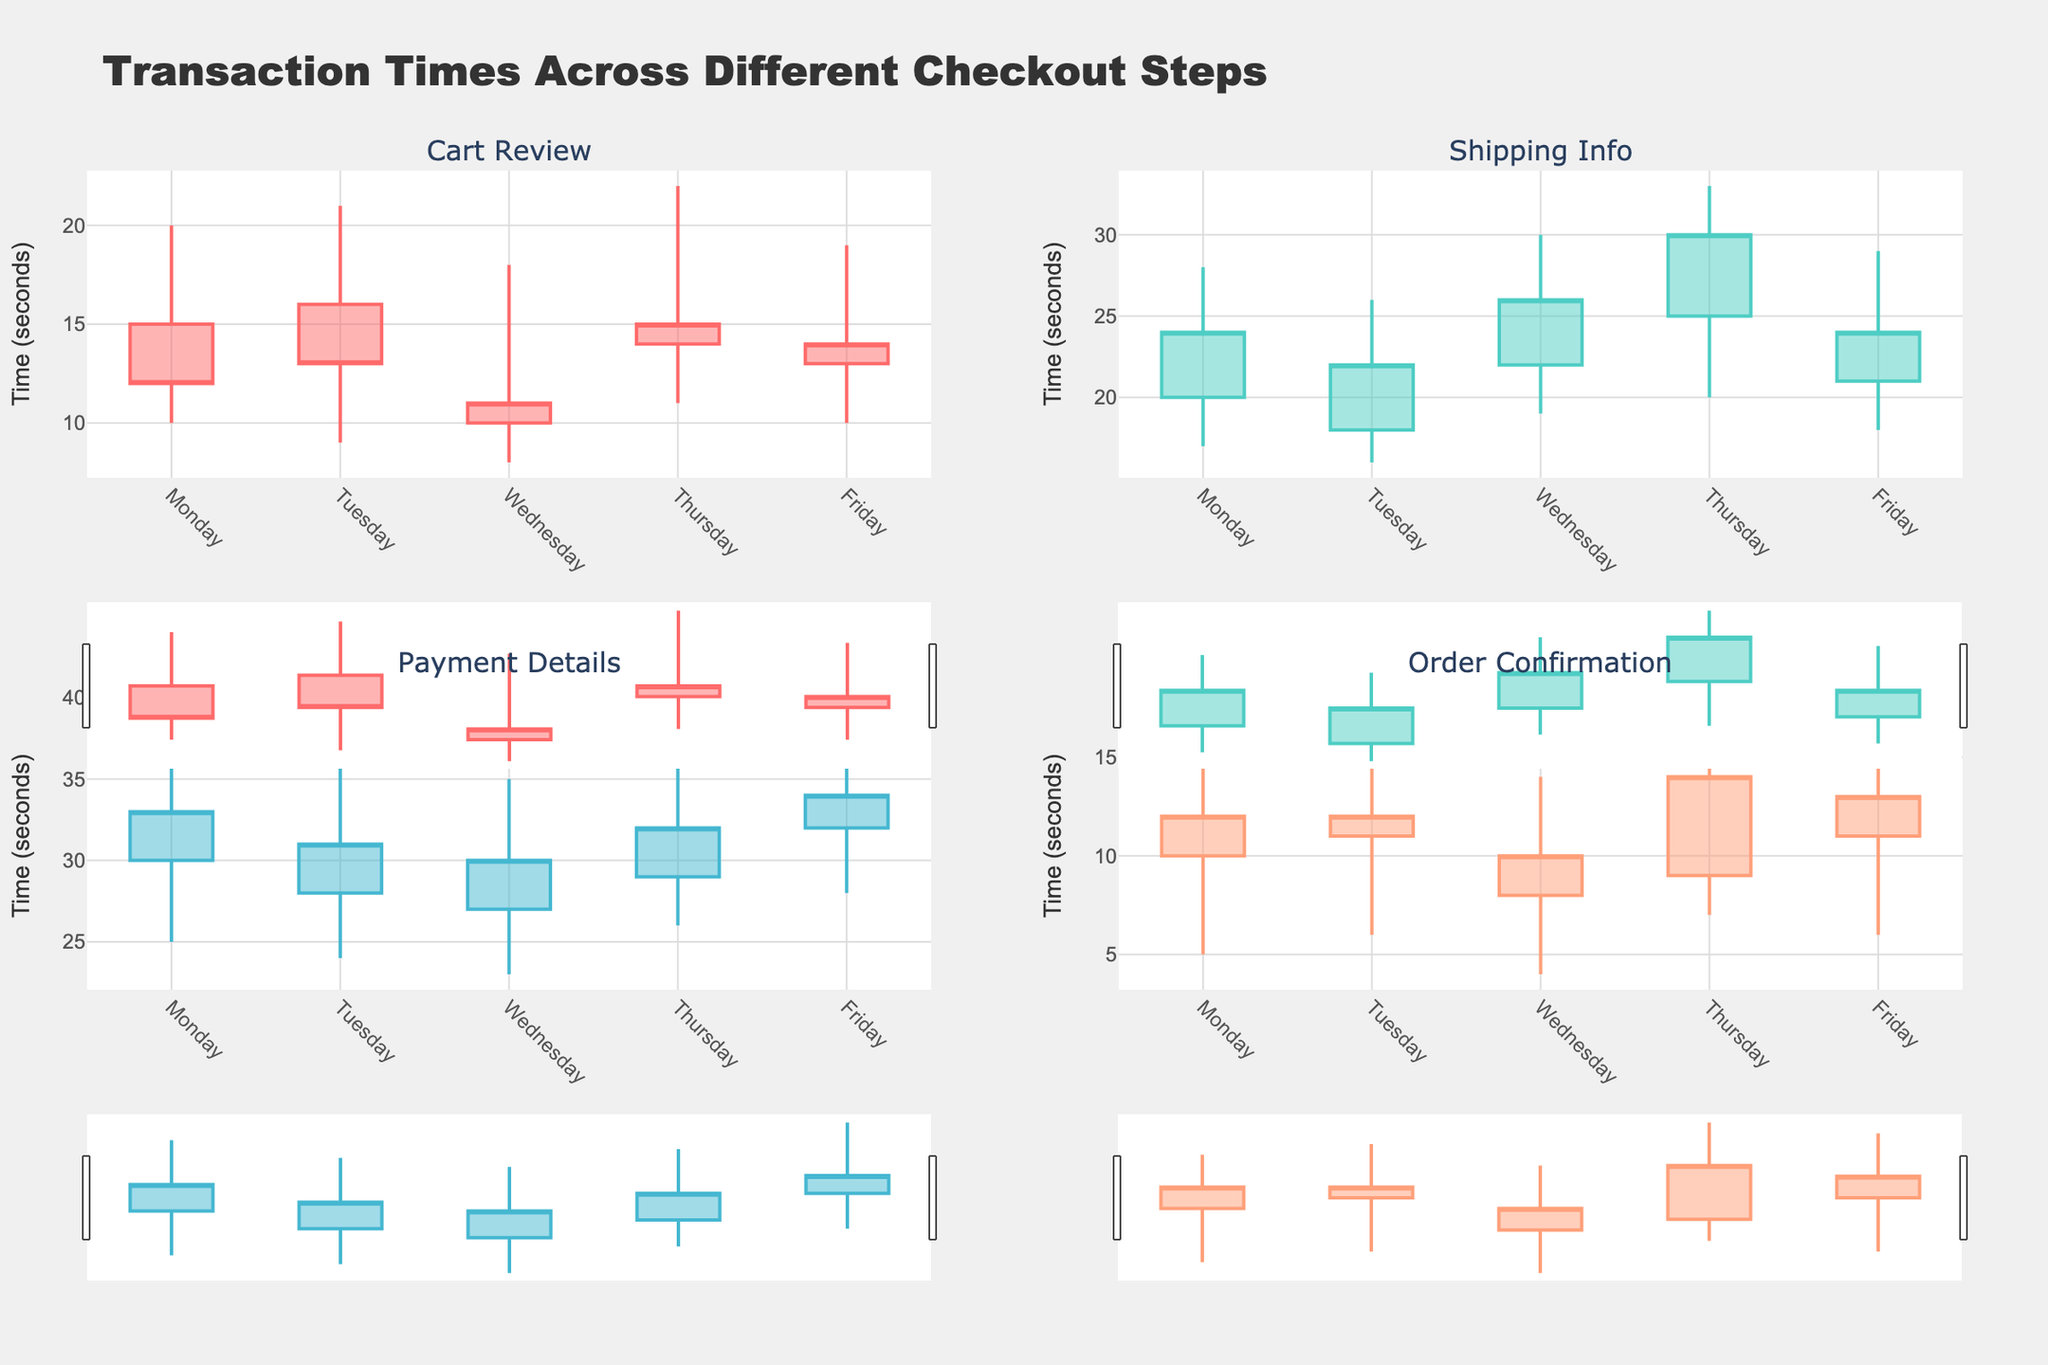What's the title of the figure? The title of the figure is shown at the top. It reads "Transaction Times Across Different Checkout Steps."
Answer: Transaction Times Across Different Checkout Steps How many checkout steps are visualized? There are four distinct checkout steps visualized, indicated by the subplot titles. These steps are Cart Review, Shipping Info, Payment Details, and Order Confirmation.
Answer: Four Which day has the highest transaction time in Payment Details? Look at the high value for each day in the Payment Details subplot. Friday shows the highest transaction time with the value reaching 40 seconds.
Answer: Friday What is the lowest transaction time for Cart Review on Monday? The low value for Cart Review on Monday can be found in the respective candlestick plot. This value is 10 seconds.
Answer: 10 seconds Compare the average transaction times on Friday for Shipping Info and Payment Details. Which one is higher? First, find the average transaction time for Friday in both subplots. For Shipping Info, the open and close values are 21 and 24 respectively, so the average is (21+24)/2 = 22.5 seconds. For Payment Details, the open value is 32 and the close value is 34, so the average is (32+34)/2 = 33 seconds. Therefore, the average transaction time on Friday is higher for Payment Details.
Answer: Payment Details Which day has the smallest range of transaction times for Order Confirmation? Calculate the range (high - low) for each day in the Order Confirmation subplot. The smallest range is on Monday, with a high of 15 and a low of 5, resulting in a range of 10 seconds.
Answer: Monday On which day does the Cart Review step have the highest closing transaction time? Check the closing values for each day in the Cart Review subplot. The highest closing transaction time is on Thursday with a value of 15 seconds.
Answer: Thursday Do transaction times for Shipping Info generally increase, decrease, or stay stable over the week? Observe the overall trend from Monday to Friday in the Shipping Info subplot. The open, high, low, and close values generally increase over the week.
Answer: Increase Which checkout step shows the most variability in transaction times throughout the week? The variability can be inferred from the range between high and low values across the week. Payment Details has the widest range, with the highest high value of 40 and the lowest low value of 23.
Answer: Payment Details 